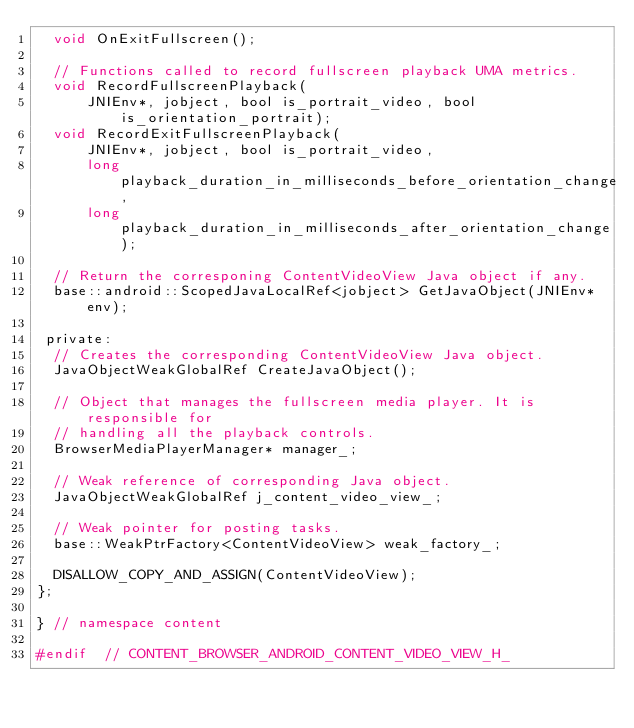<code> <loc_0><loc_0><loc_500><loc_500><_C_>  void OnExitFullscreen();

  // Functions called to record fullscreen playback UMA metrics.
  void RecordFullscreenPlayback(
      JNIEnv*, jobject, bool is_portrait_video, bool is_orientation_portrait);
  void RecordExitFullscreenPlayback(
      JNIEnv*, jobject, bool is_portrait_video,
      long playback_duration_in_milliseconds_before_orientation_change,
      long playback_duration_in_milliseconds_after_orientation_change);

  // Return the corresponing ContentVideoView Java object if any.
  base::android::ScopedJavaLocalRef<jobject> GetJavaObject(JNIEnv* env);

 private:
  // Creates the corresponding ContentVideoView Java object.
  JavaObjectWeakGlobalRef CreateJavaObject();

  // Object that manages the fullscreen media player. It is responsible for
  // handling all the playback controls.
  BrowserMediaPlayerManager* manager_;

  // Weak reference of corresponding Java object.
  JavaObjectWeakGlobalRef j_content_video_view_;

  // Weak pointer for posting tasks.
  base::WeakPtrFactory<ContentVideoView> weak_factory_;

  DISALLOW_COPY_AND_ASSIGN(ContentVideoView);
};

} // namespace content

#endif  // CONTENT_BROWSER_ANDROID_CONTENT_VIDEO_VIEW_H_
</code> 